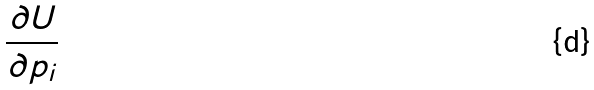Convert formula to latex. <formula><loc_0><loc_0><loc_500><loc_500>\frac { \partial U } { \partial p _ { i } }</formula> 